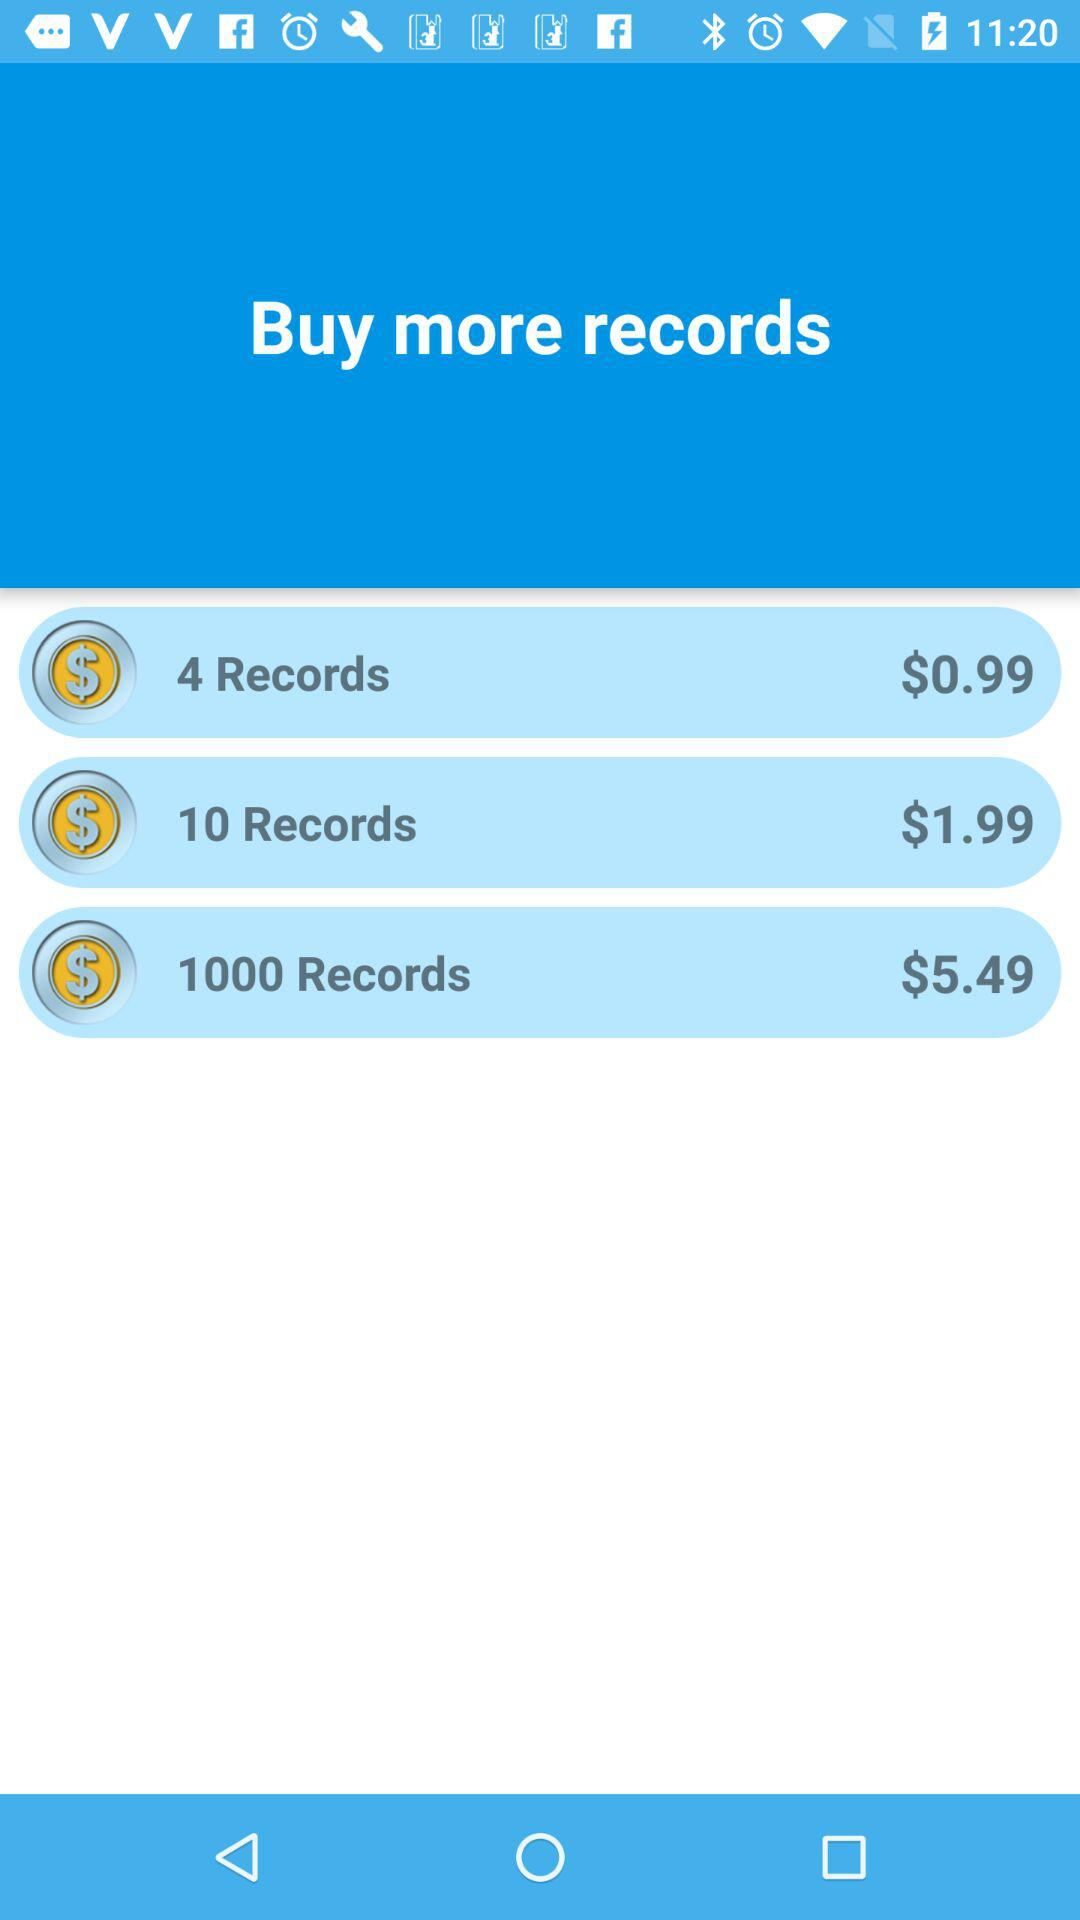What is the price of 4 records? The price is $0.99. 